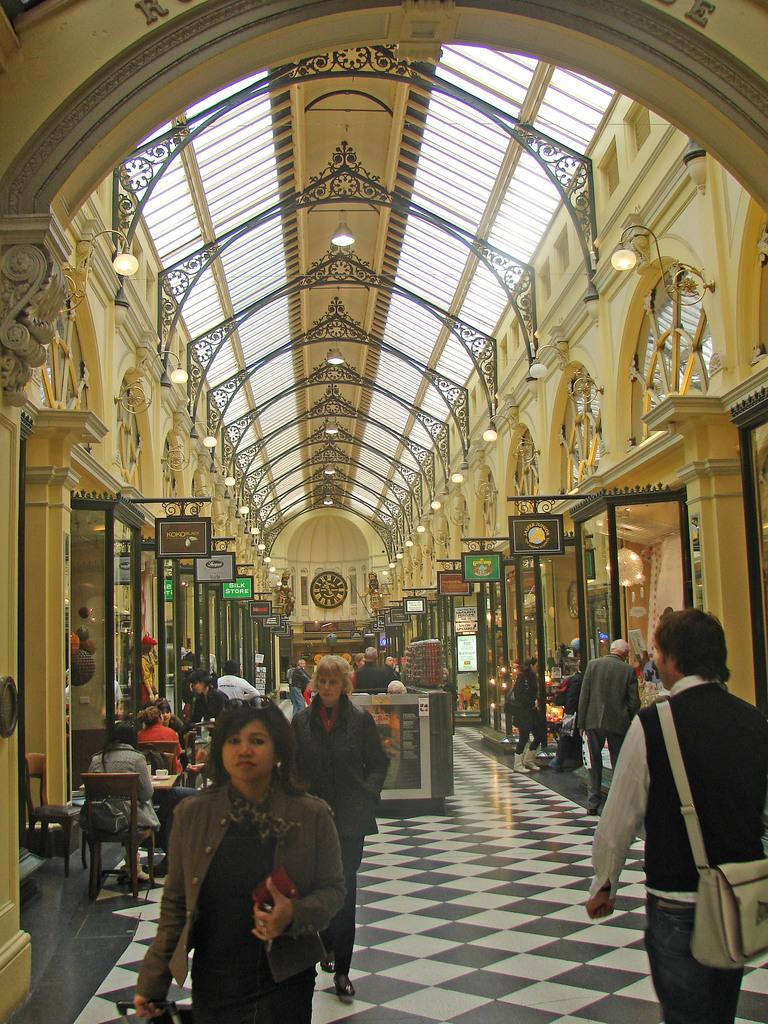What are the people in the image doing? The people in the image are walking. Where are the people walking? The people are in a hall. What can be seen in the image that provides illumination? There is light visible in the image. What type of structure can be seen in the image? There is architecture present in the image. What is on the wall in the background of the image? There is a clock on the wall in the background of the image. What type of hook is hanging from the ceiling in the image? There is no hook hanging from the ceiling in the image. What type of jeans are the people wearing in the image? The provided facts do not mention the type of clothing the people are wearing, so it cannot be determined from the image. 